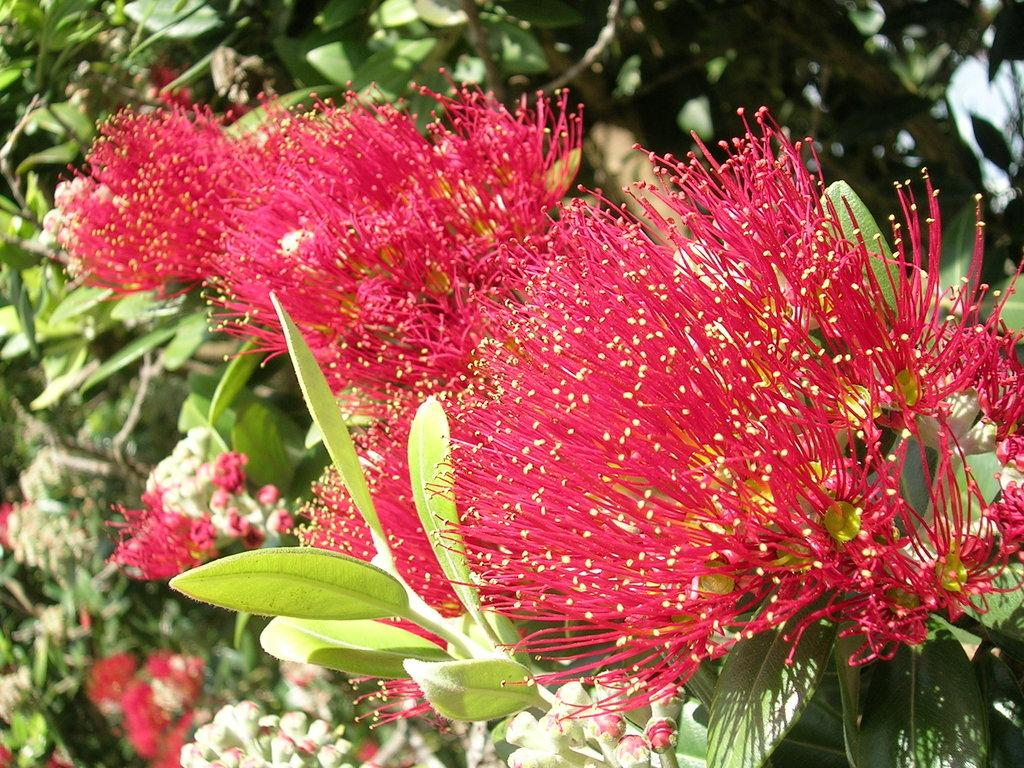What type of plant life is visible in the image? There are leaves and flowers in the image. Can you describe the stage of growth for the plants in the image? There are buds at the bottom of the image, which suggests that they are in the early stages of growth. What type of cream can be seen on the brother's shirt in the image? There is no brother or shirt present in the image; it features leaves, flowers, and buds. 